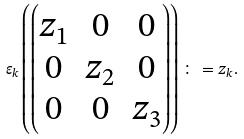<formula> <loc_0><loc_0><loc_500><loc_500>\varepsilon _ { k } \left ( \begin{pmatrix} z _ { 1 } & 0 & 0 \\ 0 & z _ { 2 } & 0 \\ 0 & 0 & z _ { 3 } \end{pmatrix} \right ) \colon = z _ { k } .</formula> 